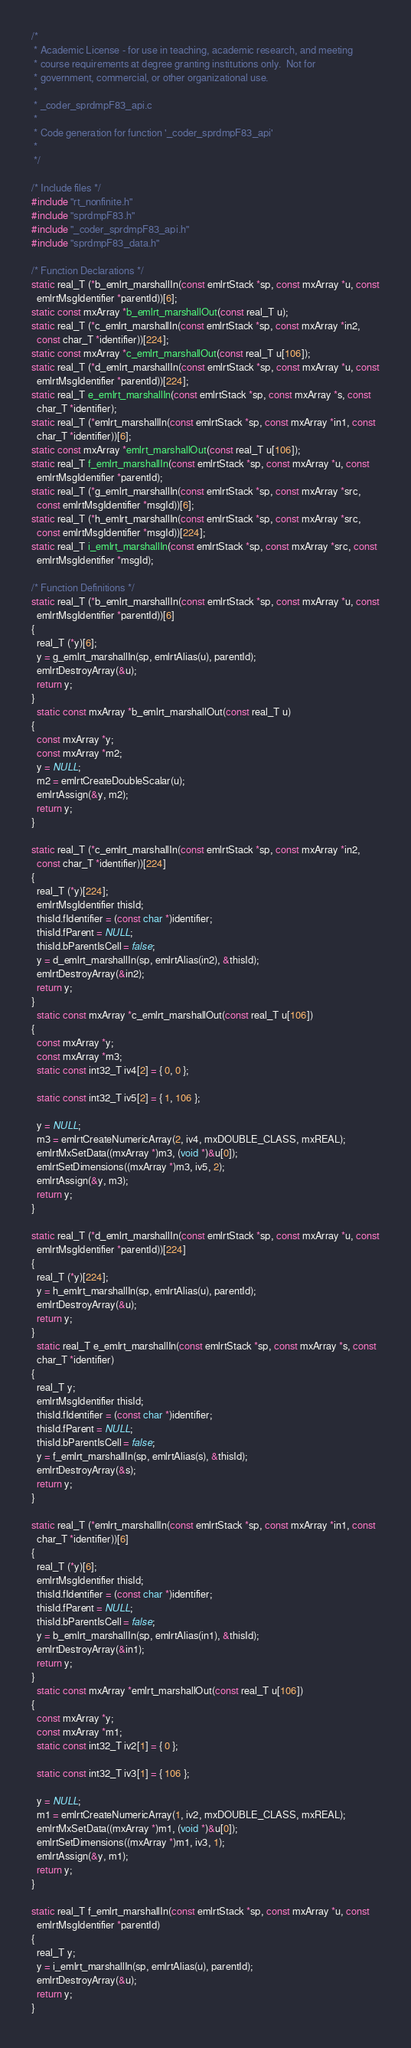Convert code to text. <code><loc_0><loc_0><loc_500><loc_500><_C_>/*
 * Academic License - for use in teaching, academic research, and meeting
 * course requirements at degree granting institutions only.  Not for
 * government, commercial, or other organizational use.
 *
 * _coder_sprdmpF83_api.c
 *
 * Code generation for function '_coder_sprdmpF83_api'
 *
 */

/* Include files */
#include "rt_nonfinite.h"
#include "sprdmpF83.h"
#include "_coder_sprdmpF83_api.h"
#include "sprdmpF83_data.h"

/* Function Declarations */
static real_T (*b_emlrt_marshallIn(const emlrtStack *sp, const mxArray *u, const
  emlrtMsgIdentifier *parentId))[6];
static const mxArray *b_emlrt_marshallOut(const real_T u);
static real_T (*c_emlrt_marshallIn(const emlrtStack *sp, const mxArray *in2,
  const char_T *identifier))[224];
static const mxArray *c_emlrt_marshallOut(const real_T u[106]);
static real_T (*d_emlrt_marshallIn(const emlrtStack *sp, const mxArray *u, const
  emlrtMsgIdentifier *parentId))[224];
static real_T e_emlrt_marshallIn(const emlrtStack *sp, const mxArray *s, const
  char_T *identifier);
static real_T (*emlrt_marshallIn(const emlrtStack *sp, const mxArray *in1, const
  char_T *identifier))[6];
static const mxArray *emlrt_marshallOut(const real_T u[106]);
static real_T f_emlrt_marshallIn(const emlrtStack *sp, const mxArray *u, const
  emlrtMsgIdentifier *parentId);
static real_T (*g_emlrt_marshallIn(const emlrtStack *sp, const mxArray *src,
  const emlrtMsgIdentifier *msgId))[6];
static real_T (*h_emlrt_marshallIn(const emlrtStack *sp, const mxArray *src,
  const emlrtMsgIdentifier *msgId))[224];
static real_T i_emlrt_marshallIn(const emlrtStack *sp, const mxArray *src, const
  emlrtMsgIdentifier *msgId);

/* Function Definitions */
static real_T (*b_emlrt_marshallIn(const emlrtStack *sp, const mxArray *u, const
  emlrtMsgIdentifier *parentId))[6]
{
  real_T (*y)[6];
  y = g_emlrt_marshallIn(sp, emlrtAlias(u), parentId);
  emlrtDestroyArray(&u);
  return y;
}
  static const mxArray *b_emlrt_marshallOut(const real_T u)
{
  const mxArray *y;
  const mxArray *m2;
  y = NULL;
  m2 = emlrtCreateDoubleScalar(u);
  emlrtAssign(&y, m2);
  return y;
}

static real_T (*c_emlrt_marshallIn(const emlrtStack *sp, const mxArray *in2,
  const char_T *identifier))[224]
{
  real_T (*y)[224];
  emlrtMsgIdentifier thisId;
  thisId.fIdentifier = (const char *)identifier;
  thisId.fParent = NULL;
  thisId.bParentIsCell = false;
  y = d_emlrt_marshallIn(sp, emlrtAlias(in2), &thisId);
  emlrtDestroyArray(&in2);
  return y;
}
  static const mxArray *c_emlrt_marshallOut(const real_T u[106])
{
  const mxArray *y;
  const mxArray *m3;
  static const int32_T iv4[2] = { 0, 0 };

  static const int32_T iv5[2] = { 1, 106 };

  y = NULL;
  m3 = emlrtCreateNumericArray(2, iv4, mxDOUBLE_CLASS, mxREAL);
  emlrtMxSetData((mxArray *)m3, (void *)&u[0]);
  emlrtSetDimensions((mxArray *)m3, iv5, 2);
  emlrtAssign(&y, m3);
  return y;
}

static real_T (*d_emlrt_marshallIn(const emlrtStack *sp, const mxArray *u, const
  emlrtMsgIdentifier *parentId))[224]
{
  real_T (*y)[224];
  y = h_emlrt_marshallIn(sp, emlrtAlias(u), parentId);
  emlrtDestroyArray(&u);
  return y;
}
  static real_T e_emlrt_marshallIn(const emlrtStack *sp, const mxArray *s, const
  char_T *identifier)
{
  real_T y;
  emlrtMsgIdentifier thisId;
  thisId.fIdentifier = (const char *)identifier;
  thisId.fParent = NULL;
  thisId.bParentIsCell = false;
  y = f_emlrt_marshallIn(sp, emlrtAlias(s), &thisId);
  emlrtDestroyArray(&s);
  return y;
}

static real_T (*emlrt_marshallIn(const emlrtStack *sp, const mxArray *in1, const
  char_T *identifier))[6]
{
  real_T (*y)[6];
  emlrtMsgIdentifier thisId;
  thisId.fIdentifier = (const char *)identifier;
  thisId.fParent = NULL;
  thisId.bParentIsCell = false;
  y = b_emlrt_marshallIn(sp, emlrtAlias(in1), &thisId);
  emlrtDestroyArray(&in1);
  return y;
}
  static const mxArray *emlrt_marshallOut(const real_T u[106])
{
  const mxArray *y;
  const mxArray *m1;
  static const int32_T iv2[1] = { 0 };

  static const int32_T iv3[1] = { 106 };

  y = NULL;
  m1 = emlrtCreateNumericArray(1, iv2, mxDOUBLE_CLASS, mxREAL);
  emlrtMxSetData((mxArray *)m1, (void *)&u[0]);
  emlrtSetDimensions((mxArray *)m1, iv3, 1);
  emlrtAssign(&y, m1);
  return y;
}

static real_T f_emlrt_marshallIn(const emlrtStack *sp, const mxArray *u, const
  emlrtMsgIdentifier *parentId)
{
  real_T y;
  y = i_emlrt_marshallIn(sp, emlrtAlias(u), parentId);
  emlrtDestroyArray(&u);
  return y;
}
</code> 